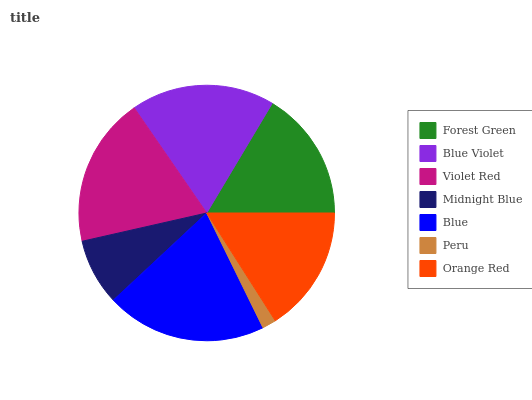Is Peru the minimum?
Answer yes or no. Yes. Is Blue the maximum?
Answer yes or no. Yes. Is Blue Violet the minimum?
Answer yes or no. No. Is Blue Violet the maximum?
Answer yes or no. No. Is Blue Violet greater than Forest Green?
Answer yes or no. Yes. Is Forest Green less than Blue Violet?
Answer yes or no. Yes. Is Forest Green greater than Blue Violet?
Answer yes or no. No. Is Blue Violet less than Forest Green?
Answer yes or no. No. Is Forest Green the high median?
Answer yes or no. Yes. Is Forest Green the low median?
Answer yes or no. Yes. Is Blue Violet the high median?
Answer yes or no. No. Is Orange Red the low median?
Answer yes or no. No. 